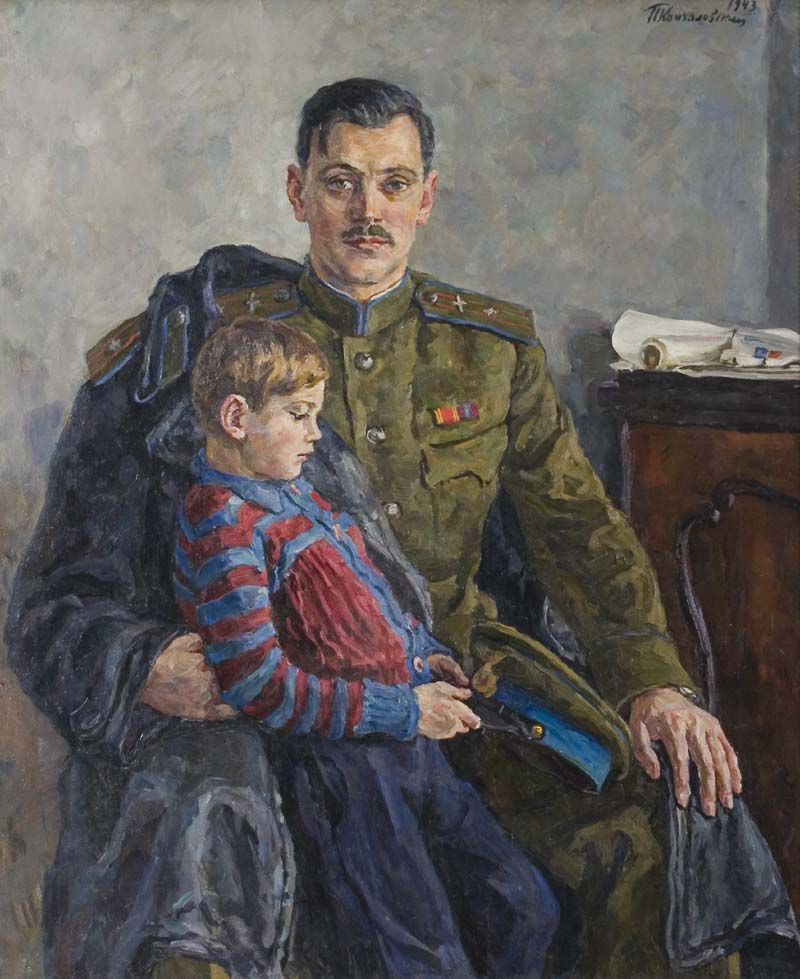What details in the painting suggest the historical period it was created in? Several elements in the painting suggest its creation during the early 20th century. The man's military uniform, adorned with medals and distinctive features such as the red stripe on the collar, is indicative of military dress from this era. The overall style of the painting, with its loose brushstrokes and muted color palette, aligns with the impressionist movement, which was prominent in the late 19th and early 20th centuries. Furthermore, the date '1913' signed by the artist, Theo van Rysselberghe, directly places the painting just before the outbreak of World War I, adding historical context to the depicted moment. 